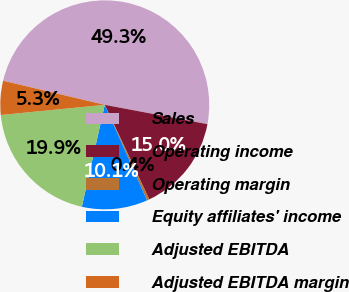Convert chart to OTSL. <chart><loc_0><loc_0><loc_500><loc_500><pie_chart><fcel>Sales<fcel>Operating income<fcel>Operating margin<fcel>Equity affiliates' income<fcel>Adjusted EBITDA<fcel>Adjusted EBITDA margin<nl><fcel>49.26%<fcel>15.04%<fcel>0.37%<fcel>10.15%<fcel>19.93%<fcel>5.26%<nl></chart> 